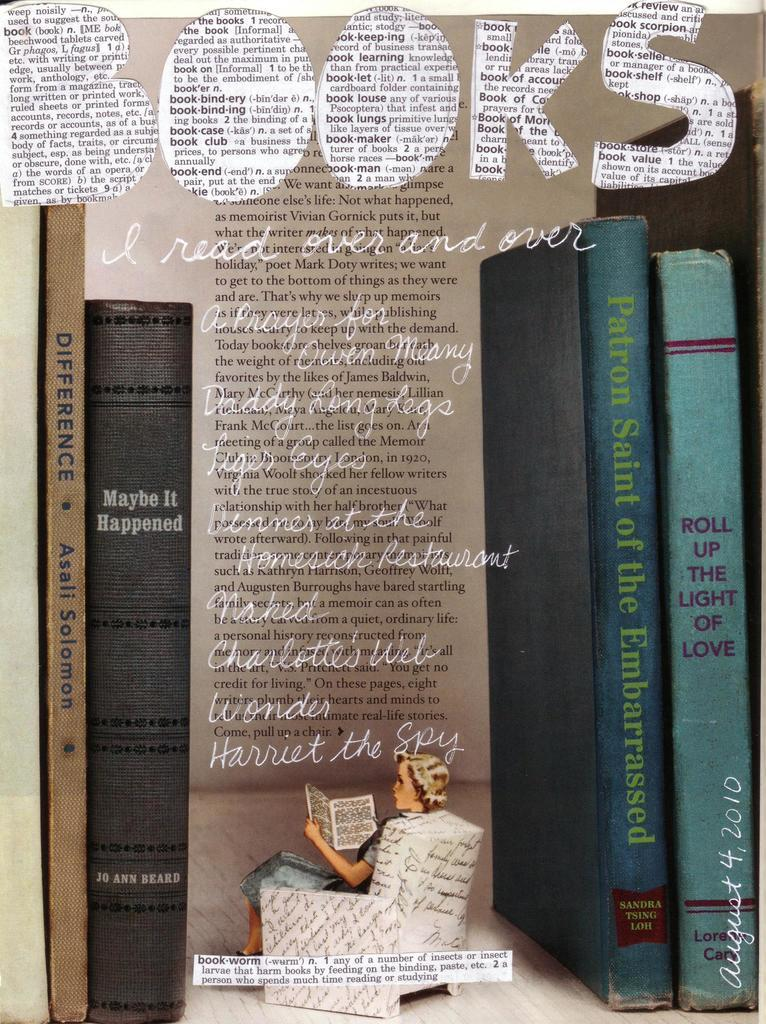<image>
Write a terse but informative summary of the picture. The front cover of a publication has the word books in large type at the top. 